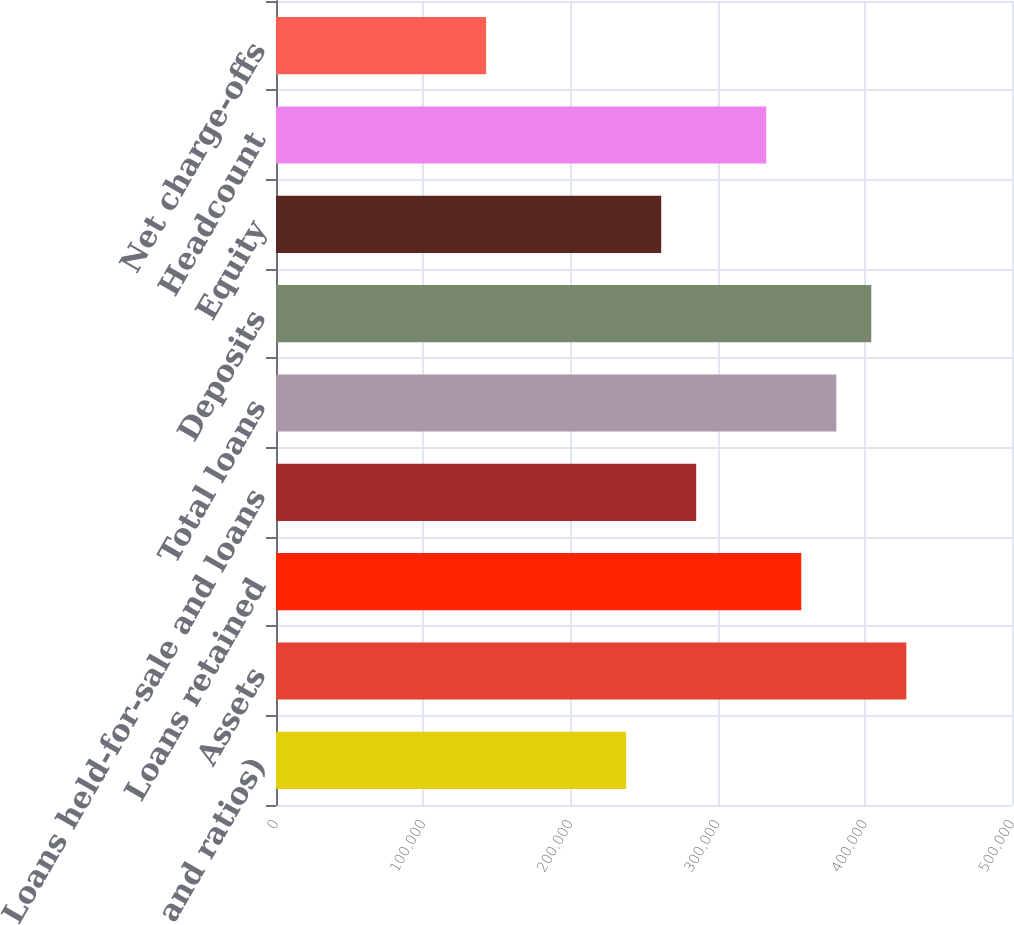Convert chart. <chart><loc_0><loc_0><loc_500><loc_500><bar_chart><fcel>and ratios)<fcel>Assets<fcel>Loans retained<fcel>Loans held-for-sale and loans<fcel>Total loans<fcel>Deposits<fcel>Equity<fcel>Headcount<fcel>Net charge-offs<nl><fcel>237887<fcel>428196<fcel>356830<fcel>285464<fcel>380619<fcel>404408<fcel>261676<fcel>333042<fcel>142732<nl></chart> 